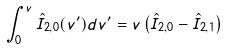Convert formula to latex. <formula><loc_0><loc_0><loc_500><loc_500>\int _ { 0 } ^ { v } \hat { I } _ { 2 , 0 } ( v ^ { \prime } ) d v ^ { \prime } = v \left ( \hat { I } _ { 2 , 0 } - \hat { I } _ { 2 , 1 } \right )</formula> 